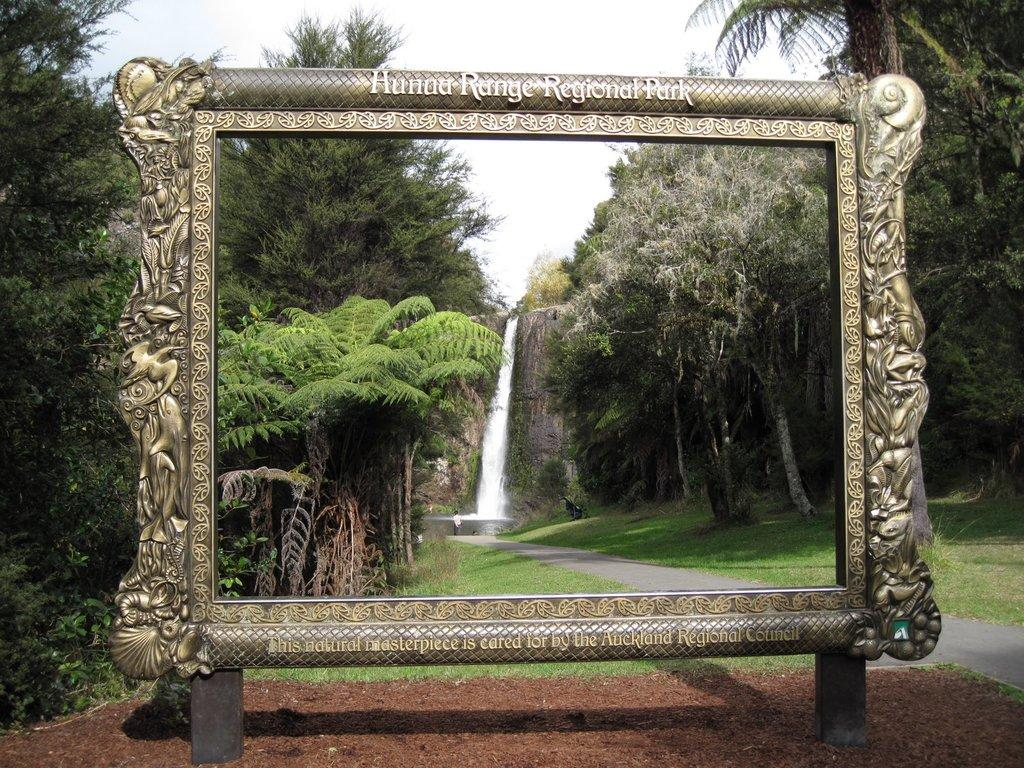What is depicted within the frame in the image? There is a frame with text in the image. What natural features can be seen in the image? There are waterfalls, grass, and trees in the image. Can you describe the person in the image? A person is standing in the image, and they are wearing clothes. What man-made structures are present in the image? There is a road in the image. What part of the natural environment is visible in the image? The sky is visible in the image. What type of insurance policy is the person holding in the image? There is no insurance policy present in the image; the person is simply standing and wearing clothes. Can you tell me how many guns are visible in the image? There are no guns present in the image. 